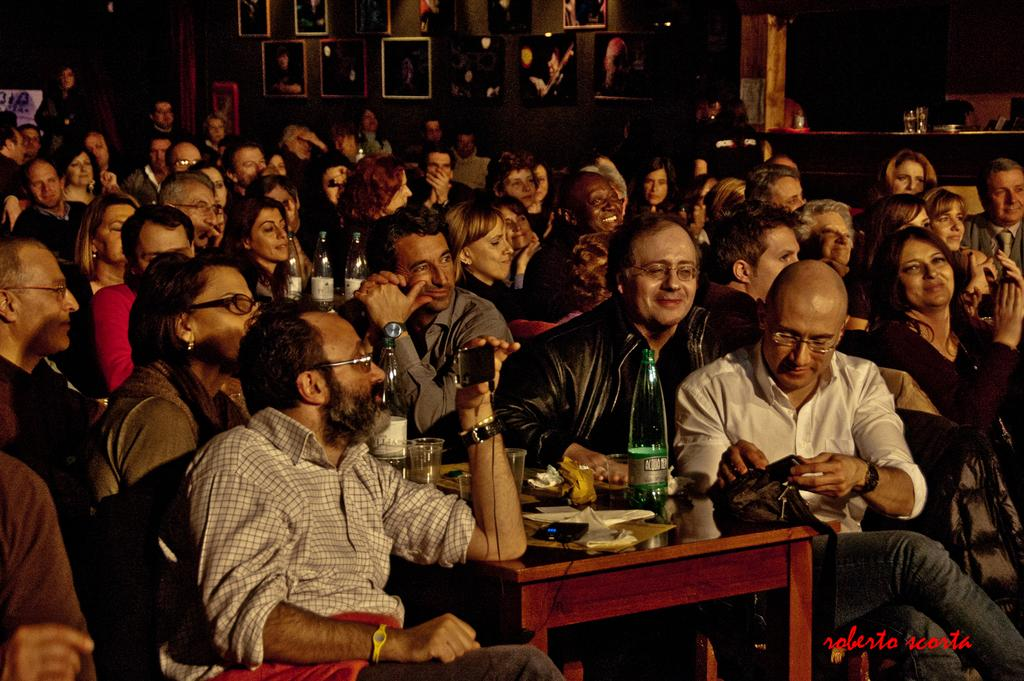How many people are in the image? There is a group of people in the image. What are the people doing in the image? The people are sitting on chairs. Where are the chairs located in relation to the table? The chairs are in front of a table. What can be seen on the table in the image? There are glass bottles and other objects on the table. What type of finger can be seen holding a glass bottle in the image? There is no finger holding a glass bottle in the image; the glass bottles are on the table. 